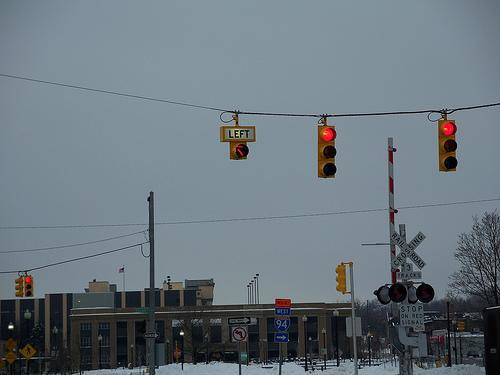Question: how many traffic lights?
Choices:
A. Three.
B. Four.
C. Six.
D. Five.
Answer with the letter. Answer: D Question: when was picture taken?
Choices:
A. Night.
B. Day.
C. Noon.
D. Dawn.
Answer with the letter. Answer: A Question: where are poles?
Choices:
A. Sidewalk.
B. Yard.
C. Lawn.
D. Street.
Answer with the letter. Answer: D Question: who is in the picture?
Choices:
A. The children.
B. Nobody.
C. The pedestrians.
D. The policemen.
Answer with the letter. Answer: B Question: what is the word at top of sign?
Choices:
A. No.
B. Stop.
C. Left.
D. Right.
Answer with the letter. Answer: C 